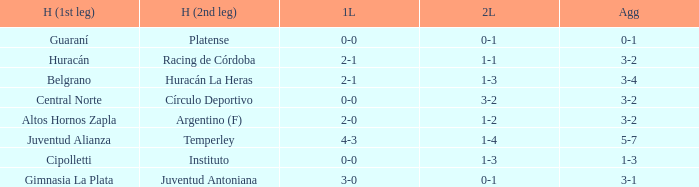Who played at home for the second leg with a score of 0-1 and tied 0-0 in the first leg? Platense. 